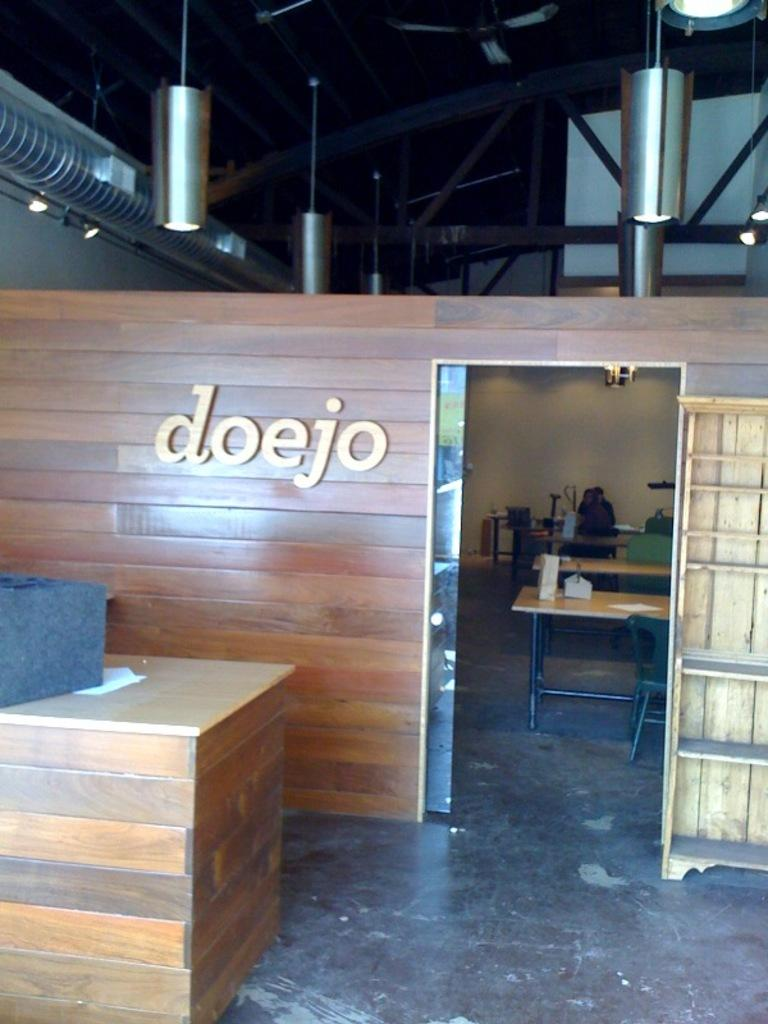<image>
Share a concise interpretation of the image provided. A wall has the letters doejo next to an entry. 